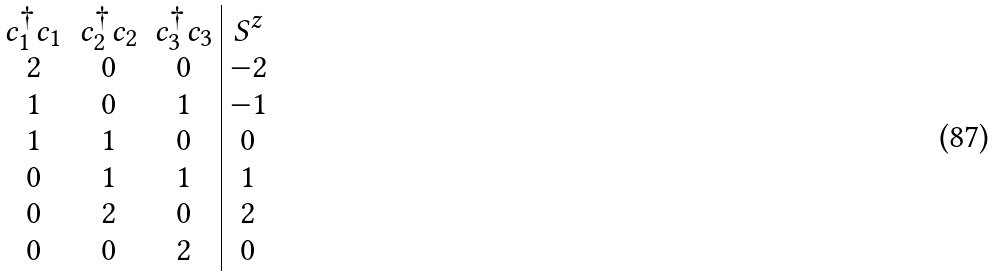<formula> <loc_0><loc_0><loc_500><loc_500>\begin{array} { c c c | c } c _ { 1 } ^ { \dagger } c _ { 1 } & c _ { 2 } ^ { \dagger } c _ { 2 } & c _ { 3 } ^ { \dagger } c _ { 3 } & S ^ { z } \\ 2 & 0 & 0 & - 2 \\ 1 & 0 & 1 & - 1 \\ 1 & 1 & 0 & 0 \\ 0 & 1 & 1 & 1 \\ 0 & 2 & 0 & 2 \\ 0 & 0 & 2 & 0 \end{array}</formula> 